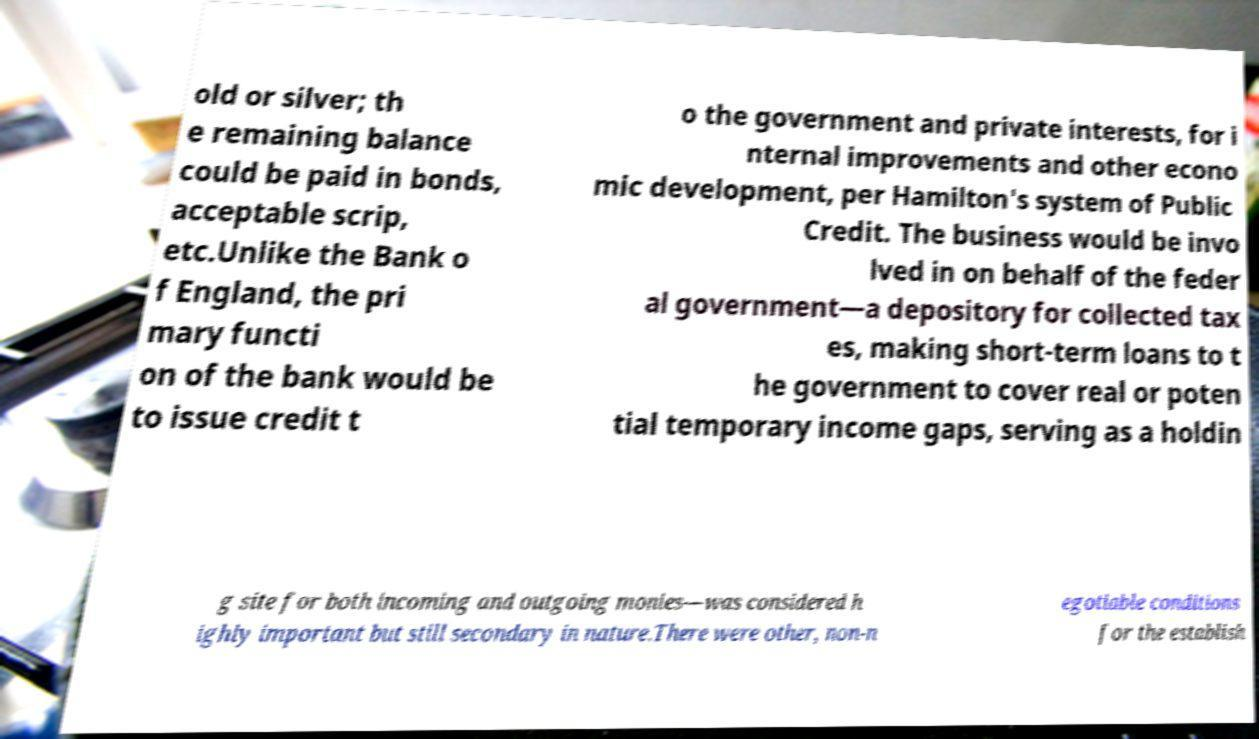For documentation purposes, I need the text within this image transcribed. Could you provide that? old or silver; th e remaining balance could be paid in bonds, acceptable scrip, etc.Unlike the Bank o f England, the pri mary functi on of the bank would be to issue credit t o the government and private interests, for i nternal improvements and other econo mic development, per Hamilton's system of Public Credit. The business would be invo lved in on behalf of the feder al government—a depository for collected tax es, making short-term loans to t he government to cover real or poten tial temporary income gaps, serving as a holdin g site for both incoming and outgoing monies—was considered h ighly important but still secondary in nature.There were other, non-n egotiable conditions for the establish 